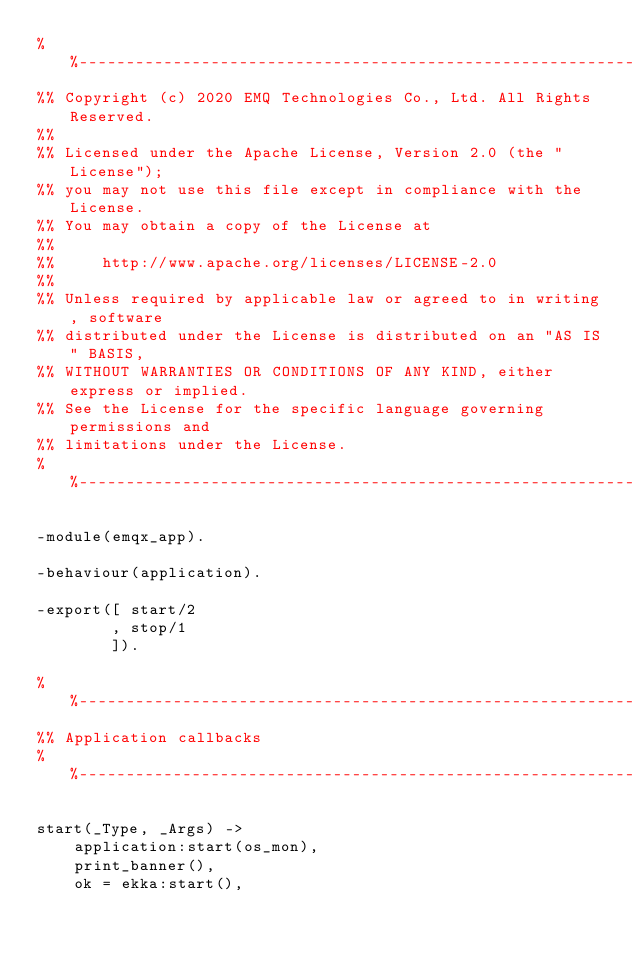Convert code to text. <code><loc_0><loc_0><loc_500><loc_500><_Erlang_>%%--------------------------------------------------------------------
%% Copyright (c) 2020 EMQ Technologies Co., Ltd. All Rights Reserved.
%%
%% Licensed under the Apache License, Version 2.0 (the "License");
%% you may not use this file except in compliance with the License.
%% You may obtain a copy of the License at
%%
%%     http://www.apache.org/licenses/LICENSE-2.0
%%
%% Unless required by applicable law or agreed to in writing, software
%% distributed under the License is distributed on an "AS IS" BASIS,
%% WITHOUT WARRANTIES OR CONDITIONS OF ANY KIND, either express or implied.
%% See the License for the specific language governing permissions and
%% limitations under the License.
%%--------------------------------------------------------------------

-module(emqx_app).

-behaviour(application).

-export([ start/2
        , stop/1
        ]).

%%--------------------------------------------------------------------
%% Application callbacks
%%--------------------------------------------------------------------

start(_Type, _Args) ->
    application:start(os_mon),
    print_banner(),
    ok = ekka:start(),</code> 